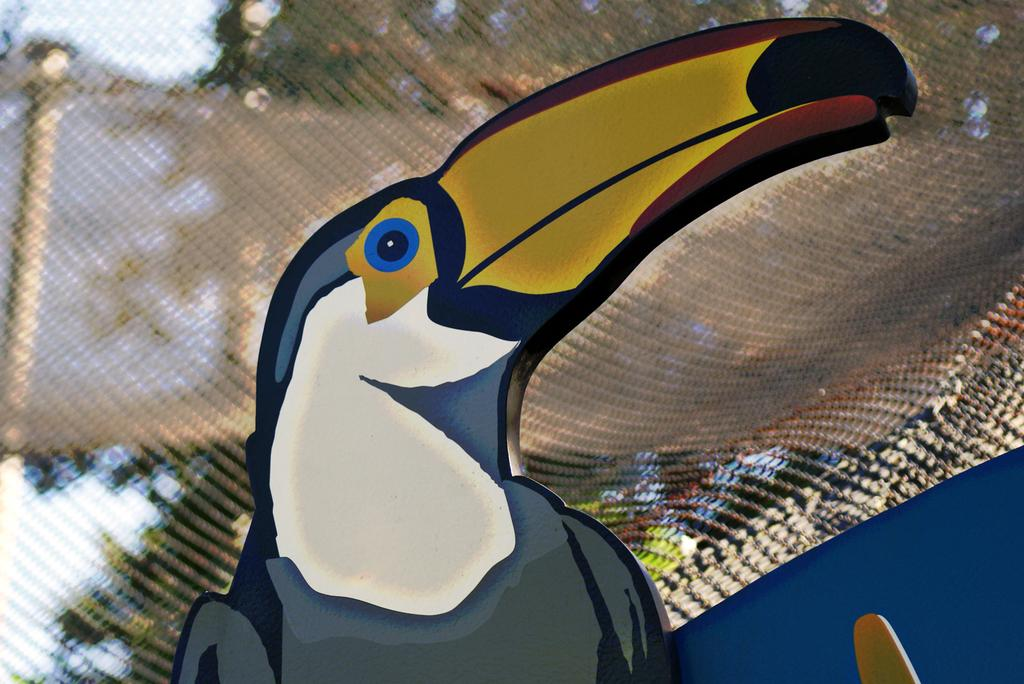What type of animal is in the image? There is a bird in the image. How close is the view of the bird? The view of the bird is close. What can be observed about the background of the image? The background of the image is blurred. What type of umbrella is being used by the bird in the image? There is no umbrella present in the image; it features a bird with a close view and a blurred background. 